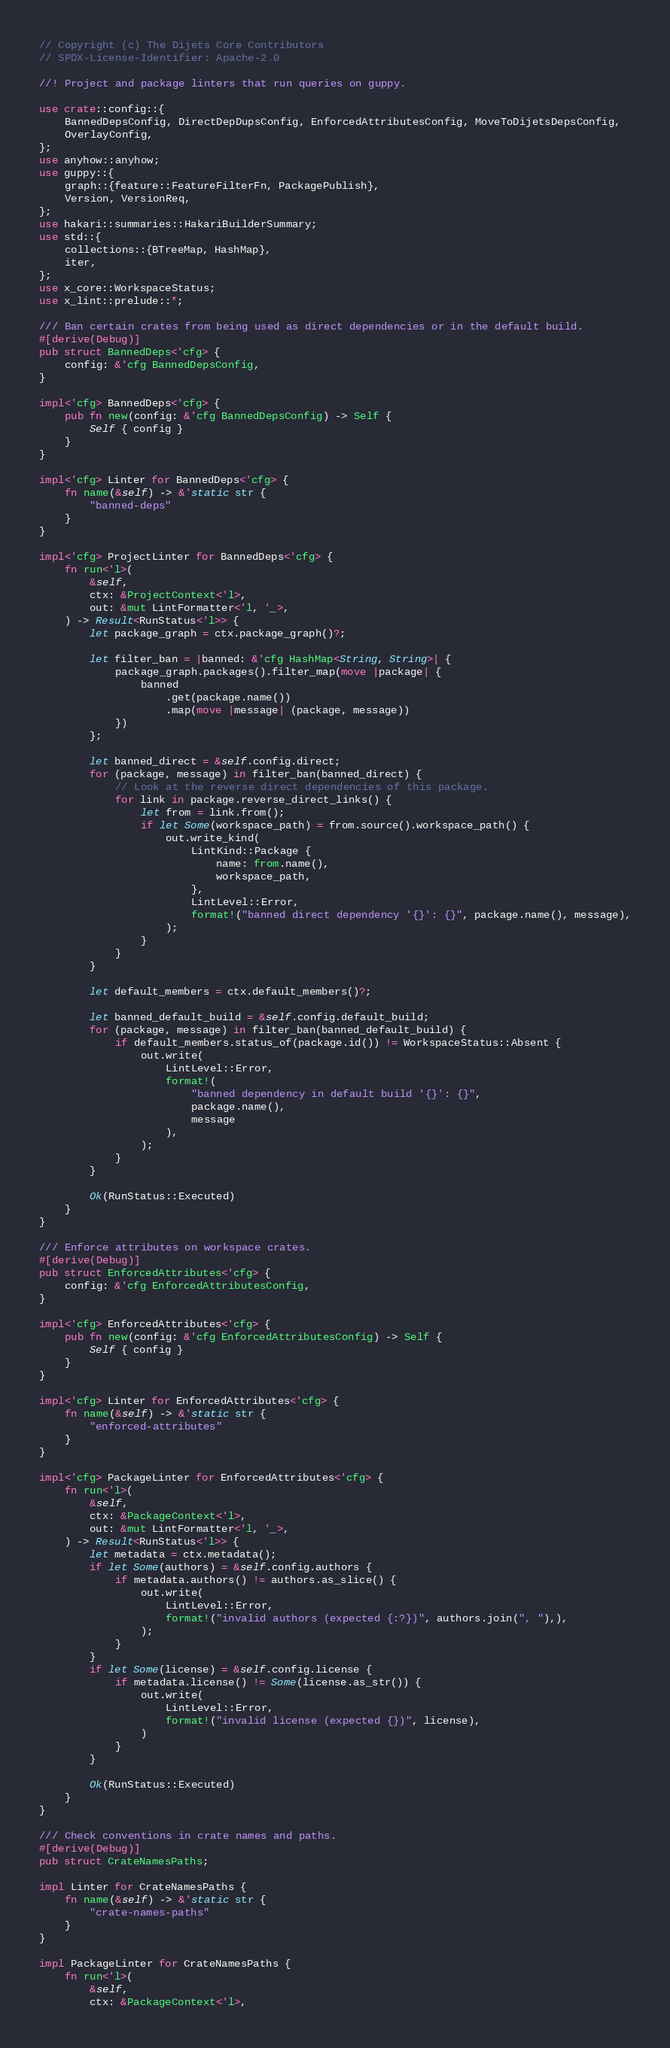<code> <loc_0><loc_0><loc_500><loc_500><_Rust_>// Copyright (c) The Dijets Core Contributors
// SPDX-License-Identifier: Apache-2.0

//! Project and package linters that run queries on guppy.

use crate::config::{
    BannedDepsConfig, DirectDepDupsConfig, EnforcedAttributesConfig, MoveToDijetsDepsConfig,
    OverlayConfig,
};
use anyhow::anyhow;
use guppy::{
    graph::{feature::FeatureFilterFn, PackagePublish},
    Version, VersionReq,
};
use hakari::summaries::HakariBuilderSummary;
use std::{
    collections::{BTreeMap, HashMap},
    iter,
};
use x_core::WorkspaceStatus;
use x_lint::prelude::*;

/// Ban certain crates from being used as direct dependencies or in the default build.
#[derive(Debug)]
pub struct BannedDeps<'cfg> {
    config: &'cfg BannedDepsConfig,
}

impl<'cfg> BannedDeps<'cfg> {
    pub fn new(config: &'cfg BannedDepsConfig) -> Self {
        Self { config }
    }
}

impl<'cfg> Linter for BannedDeps<'cfg> {
    fn name(&self) -> &'static str {
        "banned-deps"
    }
}

impl<'cfg> ProjectLinter for BannedDeps<'cfg> {
    fn run<'l>(
        &self,
        ctx: &ProjectContext<'l>,
        out: &mut LintFormatter<'l, '_>,
    ) -> Result<RunStatus<'l>> {
        let package_graph = ctx.package_graph()?;

        let filter_ban = |banned: &'cfg HashMap<String, String>| {
            package_graph.packages().filter_map(move |package| {
                banned
                    .get(package.name())
                    .map(move |message| (package, message))
            })
        };

        let banned_direct = &self.config.direct;
        for (package, message) in filter_ban(banned_direct) {
            // Look at the reverse direct dependencies of this package.
            for link in package.reverse_direct_links() {
                let from = link.from();
                if let Some(workspace_path) = from.source().workspace_path() {
                    out.write_kind(
                        LintKind::Package {
                            name: from.name(),
                            workspace_path,
                        },
                        LintLevel::Error,
                        format!("banned direct dependency '{}': {}", package.name(), message),
                    );
                }
            }
        }

        let default_members = ctx.default_members()?;

        let banned_default_build = &self.config.default_build;
        for (package, message) in filter_ban(banned_default_build) {
            if default_members.status_of(package.id()) != WorkspaceStatus::Absent {
                out.write(
                    LintLevel::Error,
                    format!(
                        "banned dependency in default build '{}': {}",
                        package.name(),
                        message
                    ),
                );
            }
        }

        Ok(RunStatus::Executed)
    }
}

/// Enforce attributes on workspace crates.
#[derive(Debug)]
pub struct EnforcedAttributes<'cfg> {
    config: &'cfg EnforcedAttributesConfig,
}

impl<'cfg> EnforcedAttributes<'cfg> {
    pub fn new(config: &'cfg EnforcedAttributesConfig) -> Self {
        Self { config }
    }
}

impl<'cfg> Linter for EnforcedAttributes<'cfg> {
    fn name(&self) -> &'static str {
        "enforced-attributes"
    }
}

impl<'cfg> PackageLinter for EnforcedAttributes<'cfg> {
    fn run<'l>(
        &self,
        ctx: &PackageContext<'l>,
        out: &mut LintFormatter<'l, '_>,
    ) -> Result<RunStatus<'l>> {
        let metadata = ctx.metadata();
        if let Some(authors) = &self.config.authors {
            if metadata.authors() != authors.as_slice() {
                out.write(
                    LintLevel::Error,
                    format!("invalid authors (expected {:?})", authors.join(", "),),
                );
            }
        }
        if let Some(license) = &self.config.license {
            if metadata.license() != Some(license.as_str()) {
                out.write(
                    LintLevel::Error,
                    format!("invalid license (expected {})", license),
                )
            }
        }

        Ok(RunStatus::Executed)
    }
}

/// Check conventions in crate names and paths.
#[derive(Debug)]
pub struct CrateNamesPaths;

impl Linter for CrateNamesPaths {
    fn name(&self) -> &'static str {
        "crate-names-paths"
    }
}

impl PackageLinter for CrateNamesPaths {
    fn run<'l>(
        &self,
        ctx: &PackageContext<'l>,</code> 